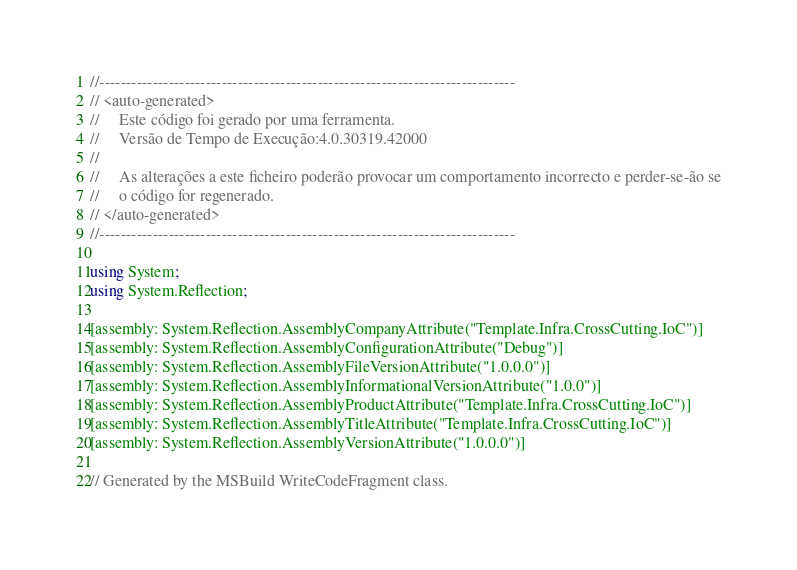Convert code to text. <code><loc_0><loc_0><loc_500><loc_500><_C#_>//------------------------------------------------------------------------------
// <auto-generated>
//     Este código foi gerado por uma ferramenta.
//     Versão de Tempo de Execução:4.0.30319.42000
//
//     As alterações a este ficheiro poderão provocar um comportamento incorrecto e perder-se-ão se
//     o código for regenerado.
// </auto-generated>
//------------------------------------------------------------------------------

using System;
using System.Reflection;

[assembly: System.Reflection.AssemblyCompanyAttribute("Template.Infra.CrossCutting.IoC")]
[assembly: System.Reflection.AssemblyConfigurationAttribute("Debug")]
[assembly: System.Reflection.AssemblyFileVersionAttribute("1.0.0.0")]
[assembly: System.Reflection.AssemblyInformationalVersionAttribute("1.0.0")]
[assembly: System.Reflection.AssemblyProductAttribute("Template.Infra.CrossCutting.IoC")]
[assembly: System.Reflection.AssemblyTitleAttribute("Template.Infra.CrossCutting.IoC")]
[assembly: System.Reflection.AssemblyVersionAttribute("1.0.0.0")]

// Generated by the MSBuild WriteCodeFragment class.

</code> 